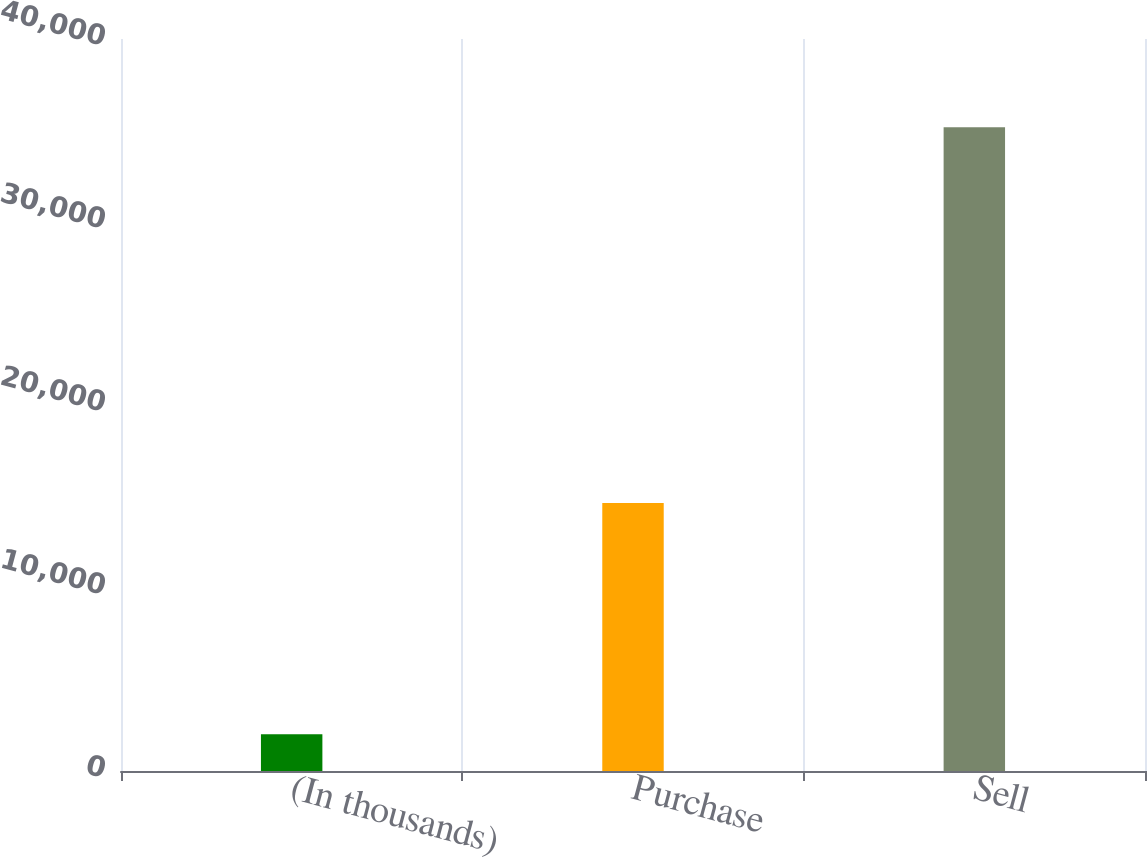Convert chart to OTSL. <chart><loc_0><loc_0><loc_500><loc_500><bar_chart><fcel>(In thousands)<fcel>Purchase<fcel>Sell<nl><fcel>2013<fcel>14641<fcel>35178<nl></chart> 